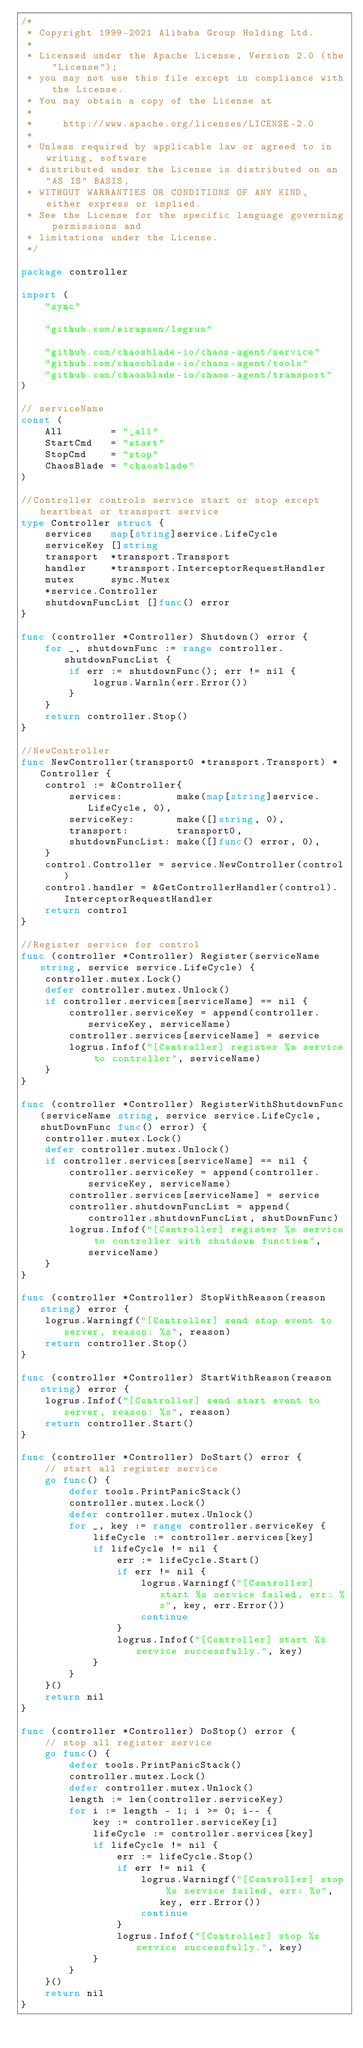Convert code to text. <code><loc_0><loc_0><loc_500><loc_500><_Go_>/*
 * Copyright 1999-2021 Alibaba Group Holding Ltd.
 *
 * Licensed under the Apache License, Version 2.0 (the "License");
 * you may not use this file except in compliance with the License.
 * You may obtain a copy of the License at
 *
 *     http://www.apache.org/licenses/LICENSE-2.0
 *
 * Unless required by applicable law or agreed to in writing, software
 * distributed under the License is distributed on an "AS IS" BASIS,
 * WITHOUT WARRANTIES OR CONDITIONS OF ANY KIND, either express or implied.
 * See the License for the specific language governing permissions and
 * limitations under the License.
 */

package controller

import (
	"sync"

	"github.com/sirupsen/logrus"

	"github.com/chaosblade-io/chaos-agent/service"
	"github.com/chaosblade-io/chaos-agent/tools"
	"github.com/chaosblade-io/chaos-agent/transport"
)

// serviceName
const (
	All        = "_all"
	StartCmd   = "start"
	StopCmd    = "stop"
	ChaosBlade = "chaosblade"
)

//Controller controls service start or stop except heartbeat or transport service
type Controller struct {
	services   map[string]service.LifeCycle
	serviceKey []string
	transport  *transport.Transport
	handler    *transport.InterceptorRequestHandler
	mutex      sync.Mutex
	*service.Controller
	shutdownFuncList []func() error
}

func (controller *Controller) Shutdown() error {
	for _, shutdownFunc := range controller.shutdownFuncList {
		if err := shutdownFunc(); err != nil {
			logrus.Warnln(err.Error())
		}
	}
	return controller.Stop()
}

//NewController
func NewController(transport0 *transport.Transport) *Controller {
	control := &Controller{
		services:         make(map[string]service.LifeCycle, 0),
		serviceKey:       make([]string, 0),
		transport:        transport0,
		shutdownFuncList: make([]func() error, 0),
	}
	control.Controller = service.NewController(control)
	control.handler = &GetControllerHandler(control).InterceptorRequestHandler
	return control
}

//Register service for control
func (controller *Controller) Register(serviceName string, service service.LifeCycle) {
	controller.mutex.Lock()
	defer controller.mutex.Unlock()
	if controller.services[serviceName] == nil {
		controller.serviceKey = append(controller.serviceKey, serviceName)
		controller.services[serviceName] = service
		logrus.Infof("[Controller] register %s service to controller", serviceName)
	}
}

func (controller *Controller) RegisterWithShutdownFunc(serviceName string, service service.LifeCycle, shutDownFunc func() error) {
	controller.mutex.Lock()
	defer controller.mutex.Unlock()
	if controller.services[serviceName] == nil {
		controller.serviceKey = append(controller.serviceKey, serviceName)
		controller.services[serviceName] = service
		controller.shutdownFuncList = append(controller.shutdownFuncList, shutDownFunc)
		logrus.Infof("[Controller] register %s service to controller with shutdown function", serviceName)
	}
}

func (controller *Controller) StopWithReason(reason string) error {
	logrus.Warningf("[Controller] send stop event to server, reason: %s", reason)
	return controller.Stop()
}

func (controller *Controller) StartWithReason(reason string) error {
	logrus.Infof("[Controller] send start event to server, reason: %s", reason)
	return controller.Start()
}

func (controller *Controller) DoStart() error {
	// start all register service
	go func() {
		defer tools.PrintPanicStack()
		controller.mutex.Lock()
		defer controller.mutex.Unlock()
		for _, key := range controller.serviceKey {
			lifeCycle := controller.services[key]
			if lifeCycle != nil {
				err := lifeCycle.Start()
				if err != nil {
					logrus.Warningf("[Controller] start %s service failed, err: %s", key, err.Error())
					continue
				}
				logrus.Infof("[Controller] start %s service successfully.", key)
			}
		}
	}()
	return nil
}

func (controller *Controller) DoStop() error {
	// stop all register service
	go func() {
		defer tools.PrintPanicStack()
		controller.mutex.Lock()
		defer controller.mutex.Unlock()
		length := len(controller.serviceKey)
		for i := length - 1; i >= 0; i-- {
			key := controller.serviceKey[i]
			lifeCycle := controller.services[key]
			if lifeCycle != nil {
				err := lifeCycle.Stop()
				if err != nil {
					logrus.Warningf("[Controller] stop %s service failed, err: %s", key, err.Error())
					continue
				}
				logrus.Infof("[Controller] stop %s service successfully.", key)
			}
		}
	}()
	return nil
}
</code> 